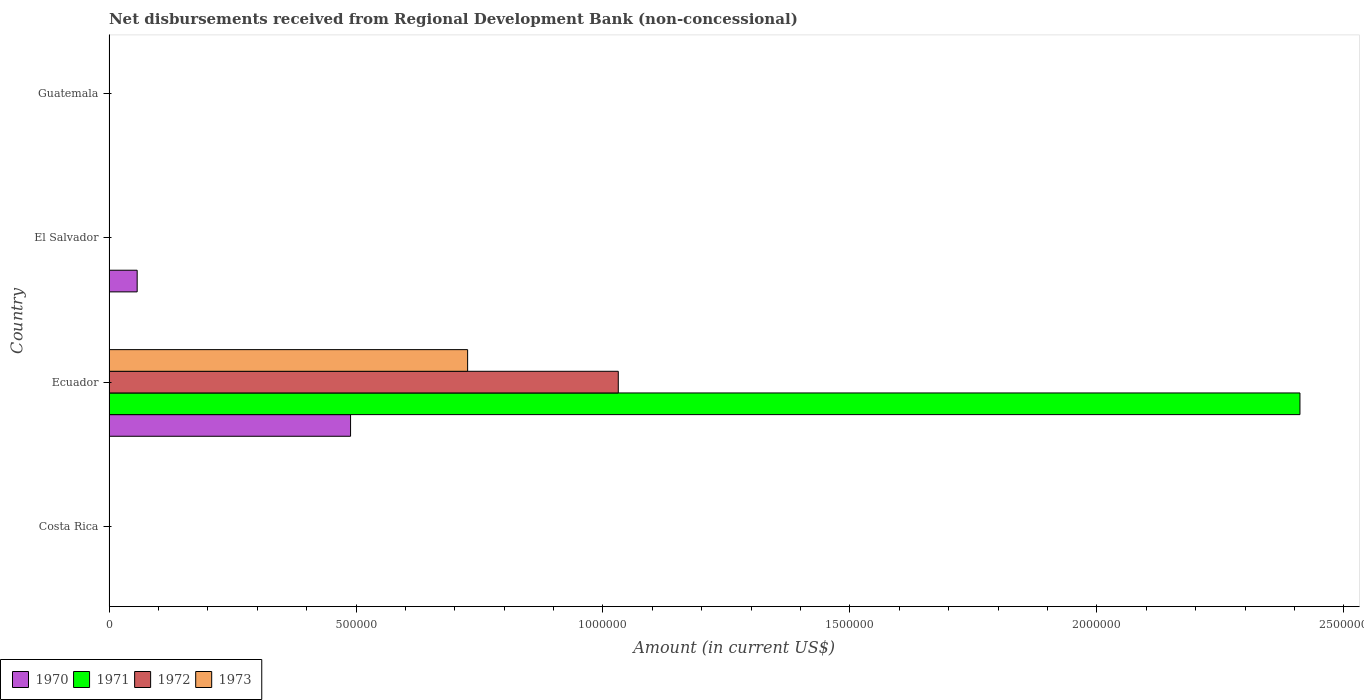Are the number of bars per tick equal to the number of legend labels?
Provide a short and direct response. No. How many bars are there on the 2nd tick from the top?
Offer a very short reply. 1. How many bars are there on the 1st tick from the bottom?
Your response must be concise. 0. What is the label of the 2nd group of bars from the top?
Make the answer very short. El Salvador. What is the amount of disbursements received from Regional Development Bank in 1971 in Ecuador?
Offer a very short reply. 2.41e+06. Across all countries, what is the maximum amount of disbursements received from Regional Development Bank in 1973?
Your response must be concise. 7.26e+05. In which country was the amount of disbursements received from Regional Development Bank in 1972 maximum?
Offer a very short reply. Ecuador. What is the total amount of disbursements received from Regional Development Bank in 1972 in the graph?
Give a very brief answer. 1.03e+06. What is the difference between the amount of disbursements received from Regional Development Bank in 1973 in Costa Rica and the amount of disbursements received from Regional Development Bank in 1970 in Ecuador?
Provide a short and direct response. -4.89e+05. What is the average amount of disbursements received from Regional Development Bank in 1973 per country?
Keep it short and to the point. 1.82e+05. In how many countries, is the amount of disbursements received from Regional Development Bank in 1973 greater than 1200000 US$?
Offer a terse response. 0. What is the difference between the highest and the lowest amount of disbursements received from Regional Development Bank in 1971?
Provide a succinct answer. 2.41e+06. Is it the case that in every country, the sum of the amount of disbursements received from Regional Development Bank in 1973 and amount of disbursements received from Regional Development Bank in 1972 is greater than the sum of amount of disbursements received from Regional Development Bank in 1971 and amount of disbursements received from Regional Development Bank in 1970?
Your answer should be compact. No. How many bars are there?
Keep it short and to the point. 5. Are all the bars in the graph horizontal?
Ensure brevity in your answer.  Yes. How many countries are there in the graph?
Ensure brevity in your answer.  4. What is the difference between two consecutive major ticks on the X-axis?
Give a very brief answer. 5.00e+05. Does the graph contain any zero values?
Ensure brevity in your answer.  Yes. Where does the legend appear in the graph?
Offer a terse response. Bottom left. How many legend labels are there?
Keep it short and to the point. 4. How are the legend labels stacked?
Your response must be concise. Horizontal. What is the title of the graph?
Give a very brief answer. Net disbursements received from Regional Development Bank (non-concessional). What is the Amount (in current US$) in 1971 in Costa Rica?
Your response must be concise. 0. What is the Amount (in current US$) in 1972 in Costa Rica?
Ensure brevity in your answer.  0. What is the Amount (in current US$) in 1970 in Ecuador?
Make the answer very short. 4.89e+05. What is the Amount (in current US$) of 1971 in Ecuador?
Keep it short and to the point. 2.41e+06. What is the Amount (in current US$) of 1972 in Ecuador?
Provide a succinct answer. 1.03e+06. What is the Amount (in current US$) in 1973 in Ecuador?
Give a very brief answer. 7.26e+05. What is the Amount (in current US$) in 1970 in El Salvador?
Your response must be concise. 5.70e+04. What is the Amount (in current US$) of 1971 in El Salvador?
Make the answer very short. 0. What is the Amount (in current US$) of 1972 in El Salvador?
Keep it short and to the point. 0. Across all countries, what is the maximum Amount (in current US$) in 1970?
Ensure brevity in your answer.  4.89e+05. Across all countries, what is the maximum Amount (in current US$) of 1971?
Offer a very short reply. 2.41e+06. Across all countries, what is the maximum Amount (in current US$) in 1972?
Keep it short and to the point. 1.03e+06. Across all countries, what is the maximum Amount (in current US$) in 1973?
Provide a short and direct response. 7.26e+05. Across all countries, what is the minimum Amount (in current US$) in 1970?
Give a very brief answer. 0. Across all countries, what is the minimum Amount (in current US$) in 1971?
Your response must be concise. 0. Across all countries, what is the minimum Amount (in current US$) in 1973?
Offer a very short reply. 0. What is the total Amount (in current US$) in 1970 in the graph?
Keep it short and to the point. 5.46e+05. What is the total Amount (in current US$) in 1971 in the graph?
Make the answer very short. 2.41e+06. What is the total Amount (in current US$) in 1972 in the graph?
Keep it short and to the point. 1.03e+06. What is the total Amount (in current US$) in 1973 in the graph?
Give a very brief answer. 7.26e+05. What is the difference between the Amount (in current US$) of 1970 in Ecuador and that in El Salvador?
Provide a succinct answer. 4.32e+05. What is the average Amount (in current US$) in 1970 per country?
Provide a short and direct response. 1.36e+05. What is the average Amount (in current US$) of 1971 per country?
Provide a short and direct response. 6.03e+05. What is the average Amount (in current US$) of 1972 per country?
Your answer should be compact. 2.58e+05. What is the average Amount (in current US$) in 1973 per country?
Your response must be concise. 1.82e+05. What is the difference between the Amount (in current US$) in 1970 and Amount (in current US$) in 1971 in Ecuador?
Offer a terse response. -1.92e+06. What is the difference between the Amount (in current US$) in 1970 and Amount (in current US$) in 1972 in Ecuador?
Offer a terse response. -5.42e+05. What is the difference between the Amount (in current US$) of 1970 and Amount (in current US$) of 1973 in Ecuador?
Provide a short and direct response. -2.37e+05. What is the difference between the Amount (in current US$) of 1971 and Amount (in current US$) of 1972 in Ecuador?
Your answer should be compact. 1.38e+06. What is the difference between the Amount (in current US$) of 1971 and Amount (in current US$) of 1973 in Ecuador?
Provide a succinct answer. 1.68e+06. What is the difference between the Amount (in current US$) of 1972 and Amount (in current US$) of 1973 in Ecuador?
Provide a succinct answer. 3.05e+05. What is the ratio of the Amount (in current US$) in 1970 in Ecuador to that in El Salvador?
Your answer should be very brief. 8.58. What is the difference between the highest and the lowest Amount (in current US$) in 1970?
Keep it short and to the point. 4.89e+05. What is the difference between the highest and the lowest Amount (in current US$) in 1971?
Your answer should be compact. 2.41e+06. What is the difference between the highest and the lowest Amount (in current US$) of 1972?
Provide a short and direct response. 1.03e+06. What is the difference between the highest and the lowest Amount (in current US$) of 1973?
Your answer should be very brief. 7.26e+05. 